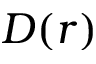<formula> <loc_0><loc_0><loc_500><loc_500>D ( r )</formula> 